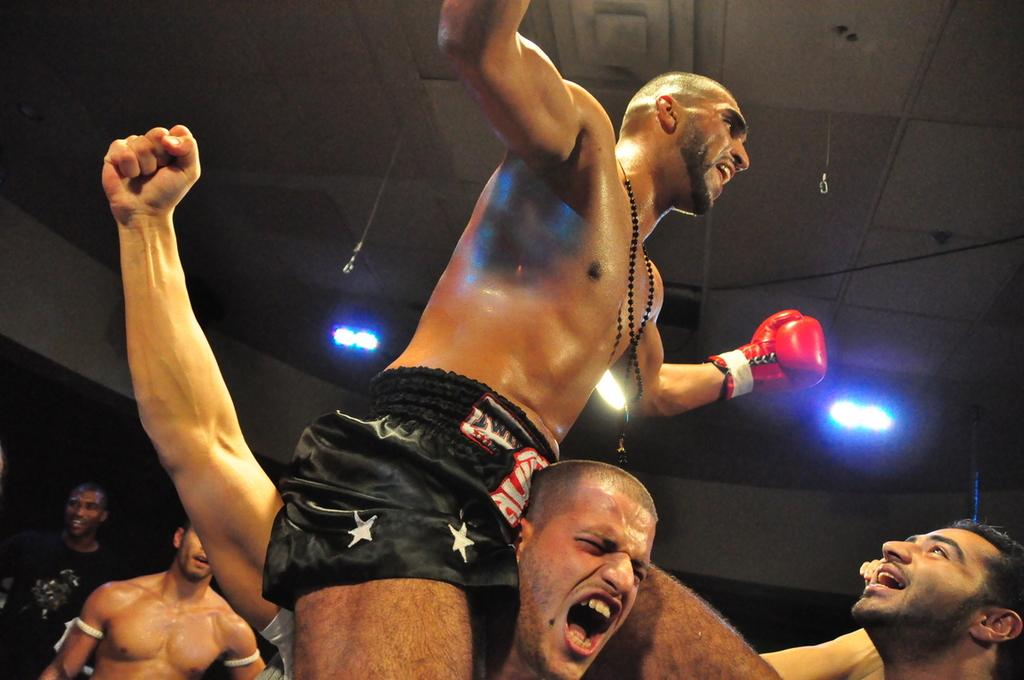What is present in the image? There are people standing in the image. What can be seen above the people in the image? There is a ceiling visible in the image. What is attached to the ceiling in the image? There are lights on the ceiling. How many goldfish are swimming in the air above the people in the image? There are no goldfish present in the image. What type of yak can be seen walking among the people in the image? There are no yaks present in the image. 